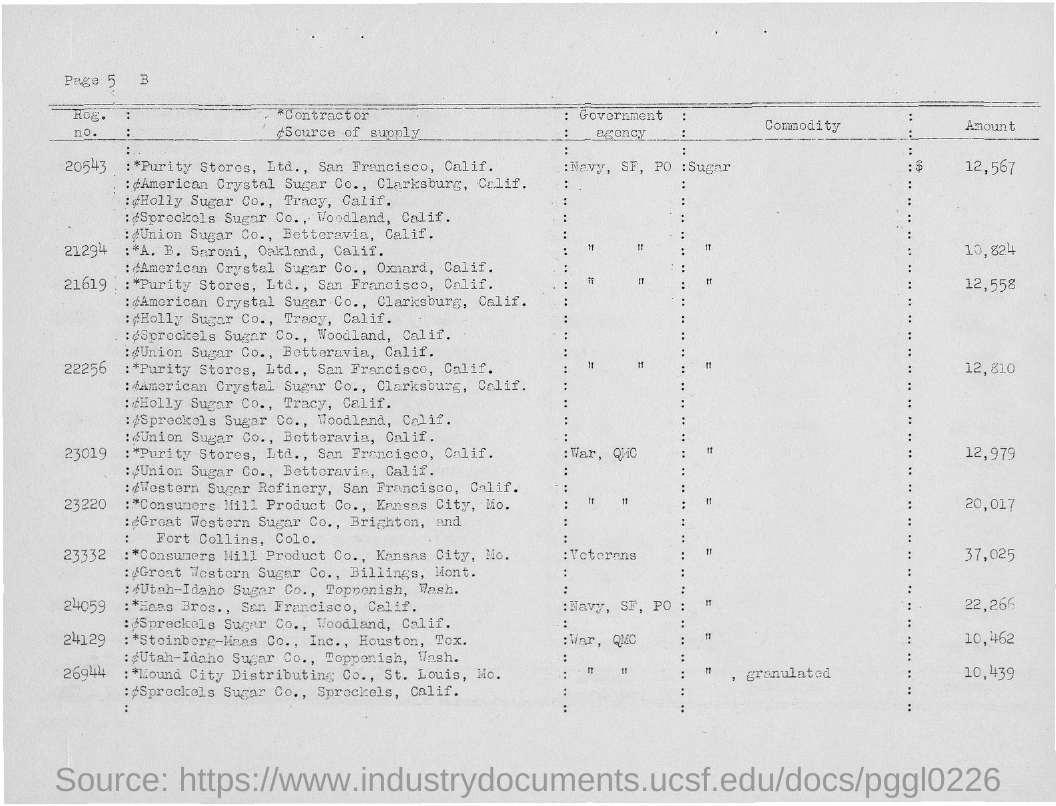What is the amount for sugar with Reg.no. 20543?
Your response must be concise. 12,567. What is the amount for sugar with Reg.no. 21294?
Keep it short and to the point. 10,824. 